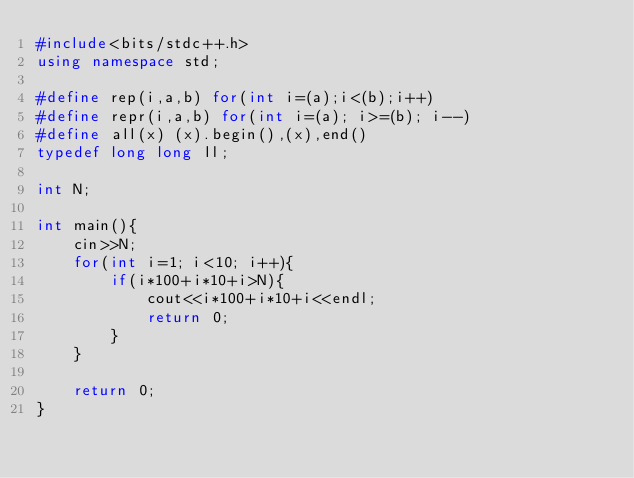<code> <loc_0><loc_0><loc_500><loc_500><_C++_>#include<bits/stdc++.h>
using namespace std;

#define rep(i,a,b) for(int i=(a);i<(b);i++)
#define repr(i,a,b) for(int i=(a); i>=(b); i--)
#define all(x) (x).begin(),(x),end()
typedef long long ll;

int N;

int main(){
    cin>>N;
    for(int i=1; i<10; i++){
        if(i*100+i*10+i>N){
            cout<<i*100+i*10+i<<endl;
            return 0;
        }
    }
    
    return 0;
}</code> 